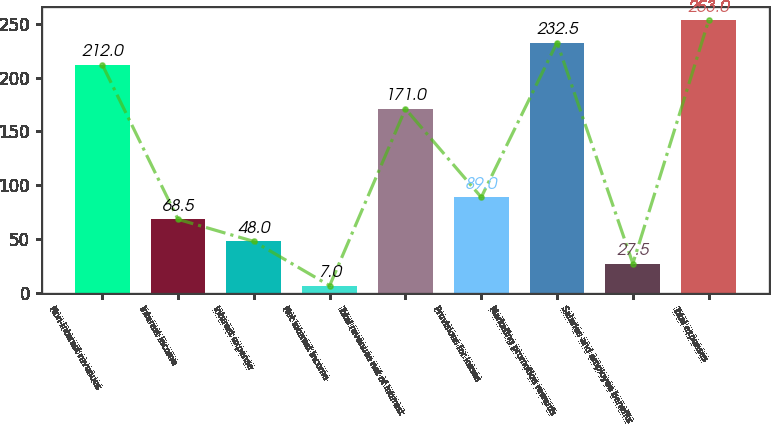Convert chart to OTSL. <chart><loc_0><loc_0><loc_500><loc_500><bar_chart><fcel>Non-interest revenues<fcel>Interest income<fcel>Interest expense<fcel>Net interest income<fcel>Total revenues net of interest<fcel>Provisions for losses<fcel>Marketing promotion rewards<fcel>Salaries and employee benefits<fcel>Total expenses<nl><fcel>212<fcel>68.5<fcel>48<fcel>7<fcel>171<fcel>89<fcel>232.5<fcel>27.5<fcel>253<nl></chart> 